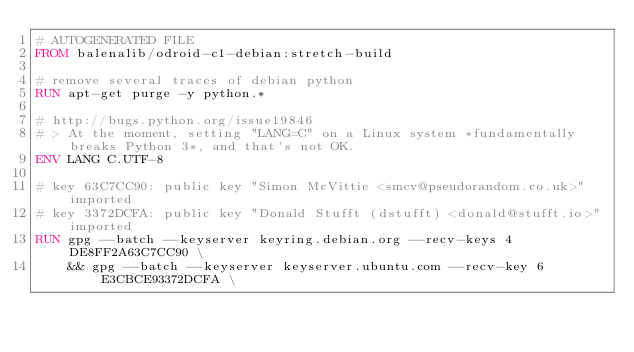Convert code to text. <code><loc_0><loc_0><loc_500><loc_500><_Dockerfile_># AUTOGENERATED FILE
FROM balenalib/odroid-c1-debian:stretch-build

# remove several traces of debian python
RUN apt-get purge -y python.*

# http://bugs.python.org/issue19846
# > At the moment, setting "LANG=C" on a Linux system *fundamentally breaks Python 3*, and that's not OK.
ENV LANG C.UTF-8

# key 63C7CC90: public key "Simon McVittie <smcv@pseudorandom.co.uk>" imported
# key 3372DCFA: public key "Donald Stufft (dstufft) <donald@stufft.io>" imported
RUN gpg --batch --keyserver keyring.debian.org --recv-keys 4DE8FF2A63C7CC90 \
    && gpg --batch --keyserver keyserver.ubuntu.com --recv-key 6E3CBCE93372DCFA \</code> 